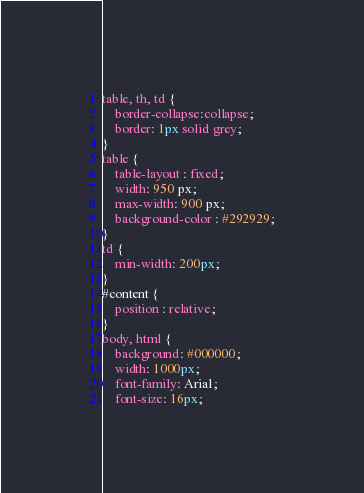<code> <loc_0><loc_0><loc_500><loc_500><_CSS_>table, th, td {
	border-collapse:collapse;
	border: 1px solid grey;
}
table {
	table-layout : fixed;
	width: 950 px;
	max-width: 900 px;
	background-color : #292929;
}
td {
	min-width: 200px;
}
#content {
	position : relative;
}
body, html {
	background: #000000;
	width: 1000px;
	font-family: Arial;
	font-size: 16px;</code> 